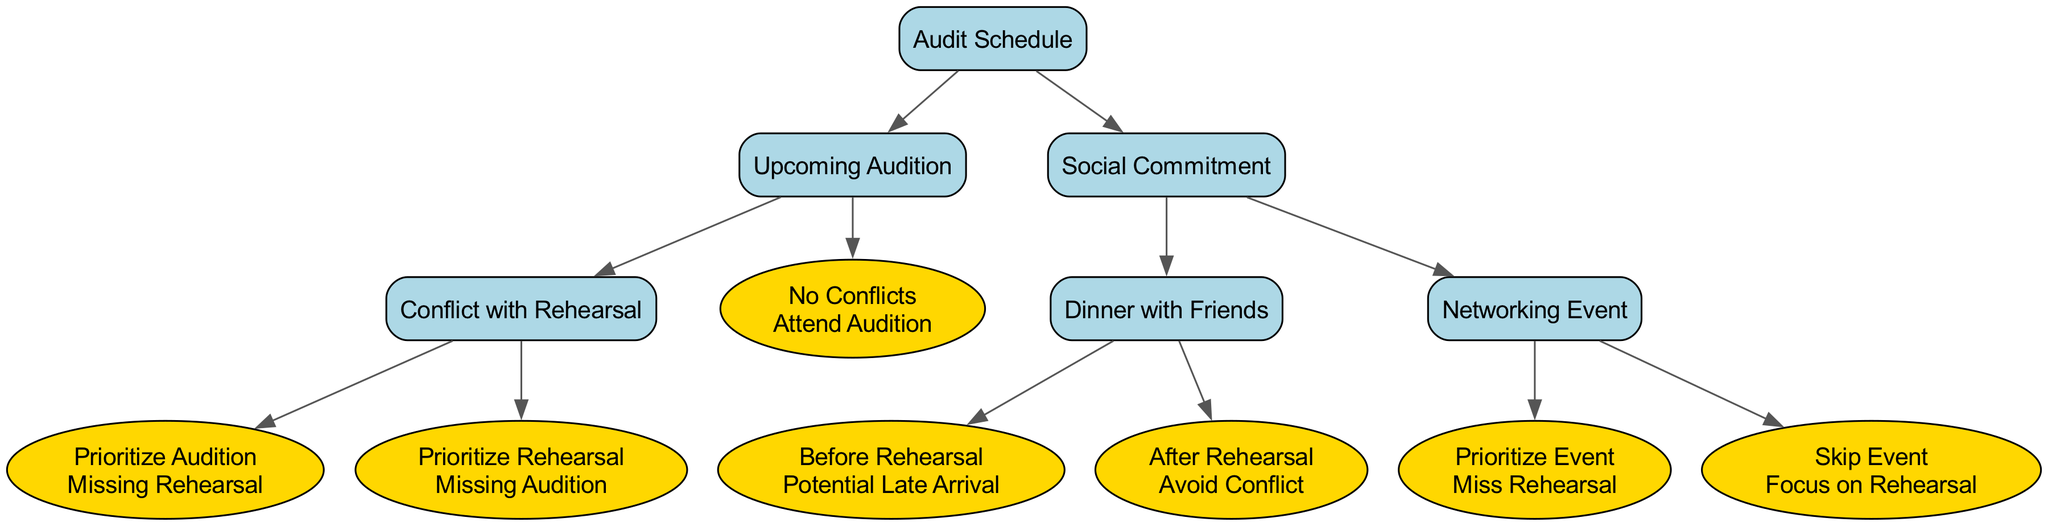What is the first decision in the tree? The first decision node in the tree is "Audit Schedule," which represents the starting point for choosing between different commitments related to auditions.
Answer: Audit Schedule How many options are available under "Upcoming Audition"? Under the "Upcoming Audition" node, there are two options: "Conflict with Rehearsal" and "No Conflicts." Therefore, there are two options available.
Answer: 2 What is the outcome if the "Prioritize Rehearsal" option is chosen? Choosing "Prioritize Rehearsal" leads to the outcome "Missing Audition," indicating that focusing on the rehearsal results in not being able to attend the audition.
Answer: Missing Audition If there is a "Dinner with Friends" before the rehearsal, what might occur? If attending the "Dinner with Friends" before the rehearsal, the diagram indicates the outcome "Potential Late Arrival," suggesting that this commitment may cause delays.
Answer: Potential Late Arrival What are the two outcomes associated with "Dinner with Friends"? The "Dinner with Friends" node has two outcomes: "Potential Late Arrival" if it is before rehearsal, and "Avoid Conflict" if it is after rehearsal. This shows the impact of timing on attendance.
Answer: Potential Late Arrival, Avoid Conflict If a networking event is prioritized, what will be missed? The diagram states that if one chooses to "Prioritize Event," the outcome will be "Miss Rehearsal," signifying a trade-off when prioritizing social commitments over rehearsals.
Answer: Miss Rehearsal What is the relationship between "Audit Schedule" and "Social Commitment"? "Audit Schedule" and "Social Commitment" are both options stemming from the initial decision node, indicating that these commitments are alternatives to be considered for time management.
Answer: Alternatives In total, how many nodes are there in the entire decision tree? The decision tree contains a total of eight nodes, including the root and all options and outcomes. This calculation includes all decision points and their respective outcomes.
Answer: 8 